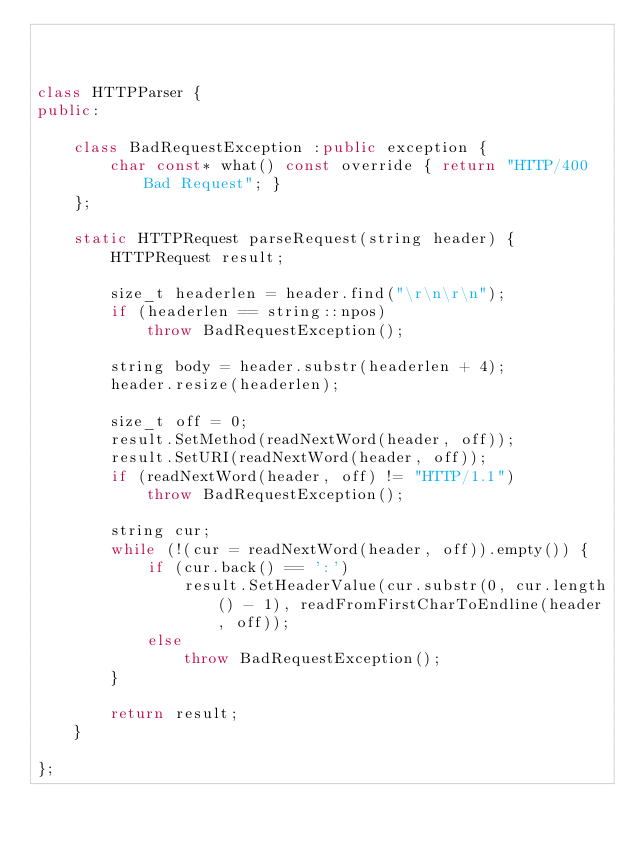Convert code to text. <code><loc_0><loc_0><loc_500><loc_500><_C++_>


class HTTPParser {
public:

	class BadRequestException :public exception {
		char const* what() const override { return "HTTP/400 Bad Request"; }
	};

	static HTTPRequest parseRequest(string header) {
		HTTPRequest result;

		size_t headerlen = header.find("\r\n\r\n");
		if (headerlen == string::npos)
			throw BadRequestException();

		string body = header.substr(headerlen + 4);
		header.resize(headerlen);

		size_t off = 0;
		result.SetMethod(readNextWord(header, off));
		result.SetURI(readNextWord(header, off));
		if (readNextWord(header, off) != "HTTP/1.1")
			throw BadRequestException();

		string cur;
		while (!(cur = readNextWord(header, off)).empty()) {
			if (cur.back() == ':')
				result.SetHeaderValue(cur.substr(0, cur.length() - 1), readFromFirstCharToEndline(header, off));
			else
				throw BadRequestException();
		}

		return result;
	}

};

</code> 